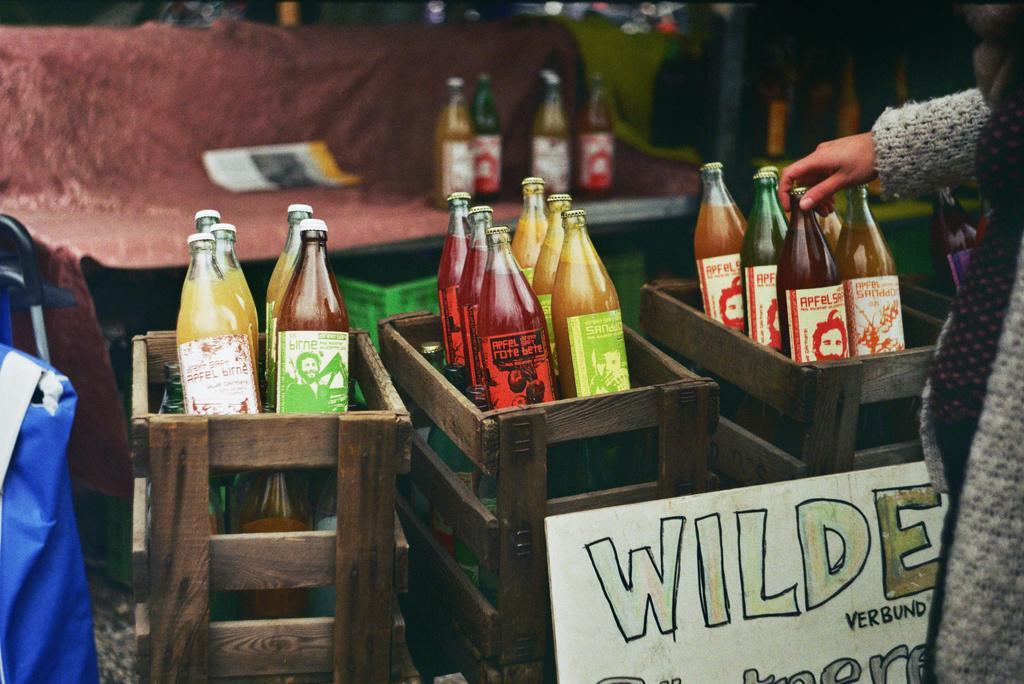Can you describe this image briefly? Here we can see bottles present in the boxes and we can see a hand of a person 